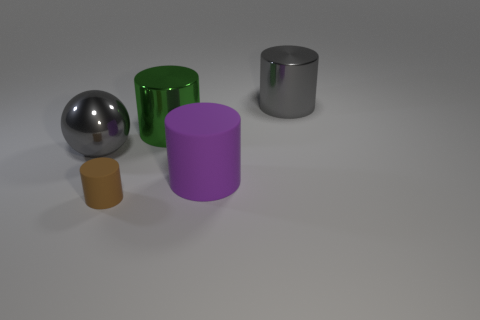Subtract all big gray metallic cylinders. How many cylinders are left? 3 Subtract all spheres. How many objects are left? 4 Subtract 4 cylinders. How many cylinders are left? 0 Subtract all green balls. Subtract all brown blocks. How many balls are left? 1 Subtract all brown cylinders. How many green spheres are left? 0 Subtract all large green cylinders. Subtract all big gray metallic balls. How many objects are left? 3 Add 5 big rubber cylinders. How many big rubber cylinders are left? 6 Add 5 large brown matte cylinders. How many large brown matte cylinders exist? 5 Add 5 large green cylinders. How many objects exist? 10 Subtract all gray cylinders. How many cylinders are left? 3 